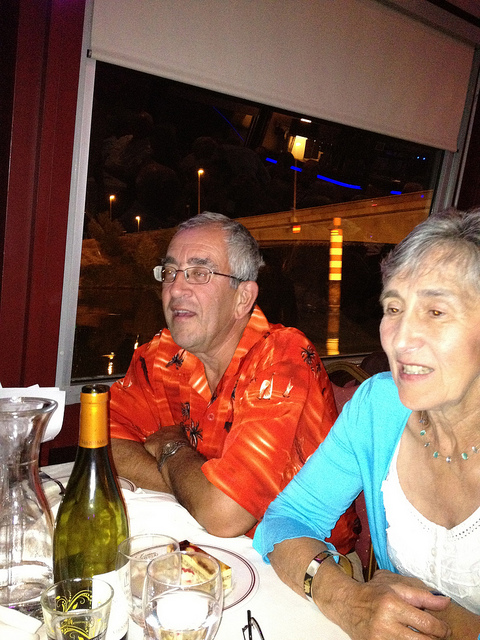Can you describe the scene in this image? This image captures a moment at a dinner table. An older gentleman wearing an orange Hawaiian shirt is seated next to an older woman in a light blue cardigan. They appear to be enjoying a meal together, set against a backdrop that features a window with a night-time view outside. 